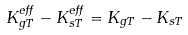<formula> <loc_0><loc_0><loc_500><loc_500>K _ { g T } ^ { e f f } - K _ { s T } ^ { e f f } = K _ { g T } - K _ { s T }</formula> 